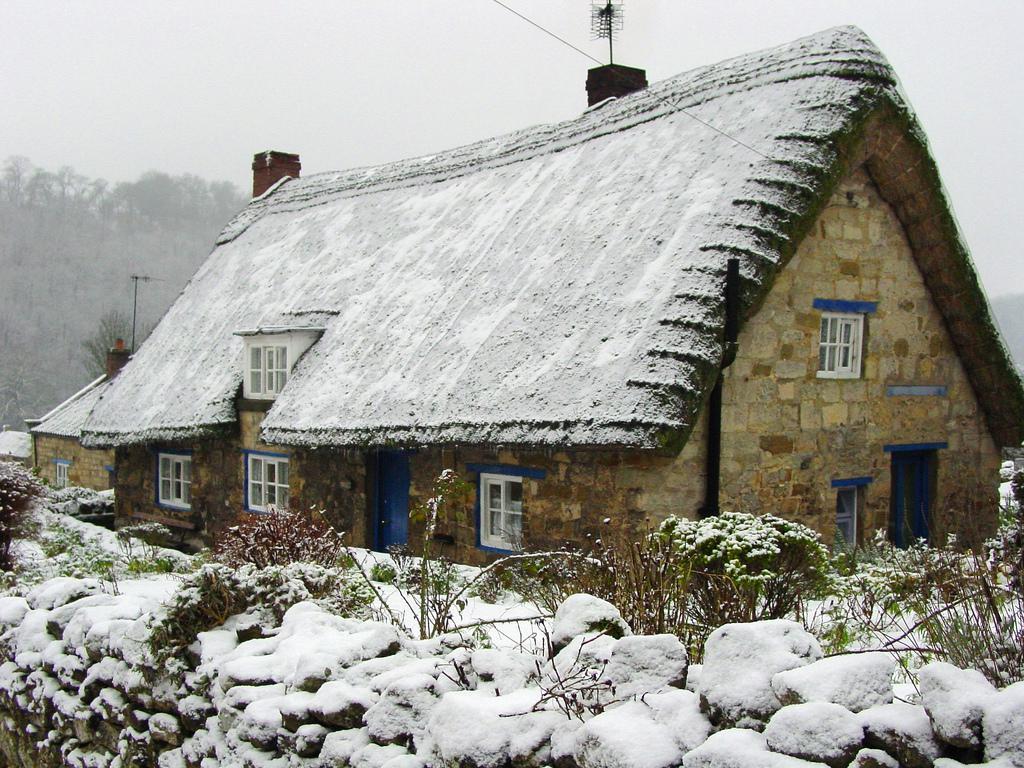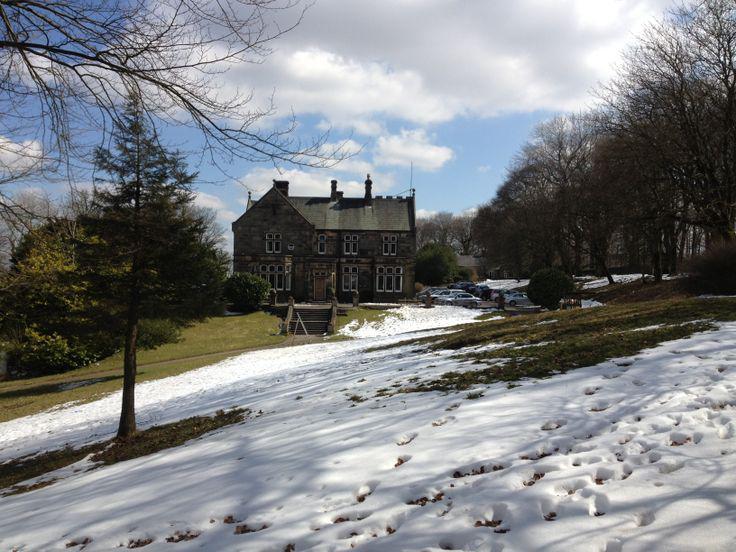The first image is the image on the left, the second image is the image on the right. Assess this claim about the two images: "There is blue sky in at least one image.". Correct or not? Answer yes or no. Yes. The first image is the image on the left, the second image is the image on the right. Considering the images on both sides, is "The right image shows snow covering a roof with two notches around paned windows on the upper story." valid? Answer yes or no. No. 